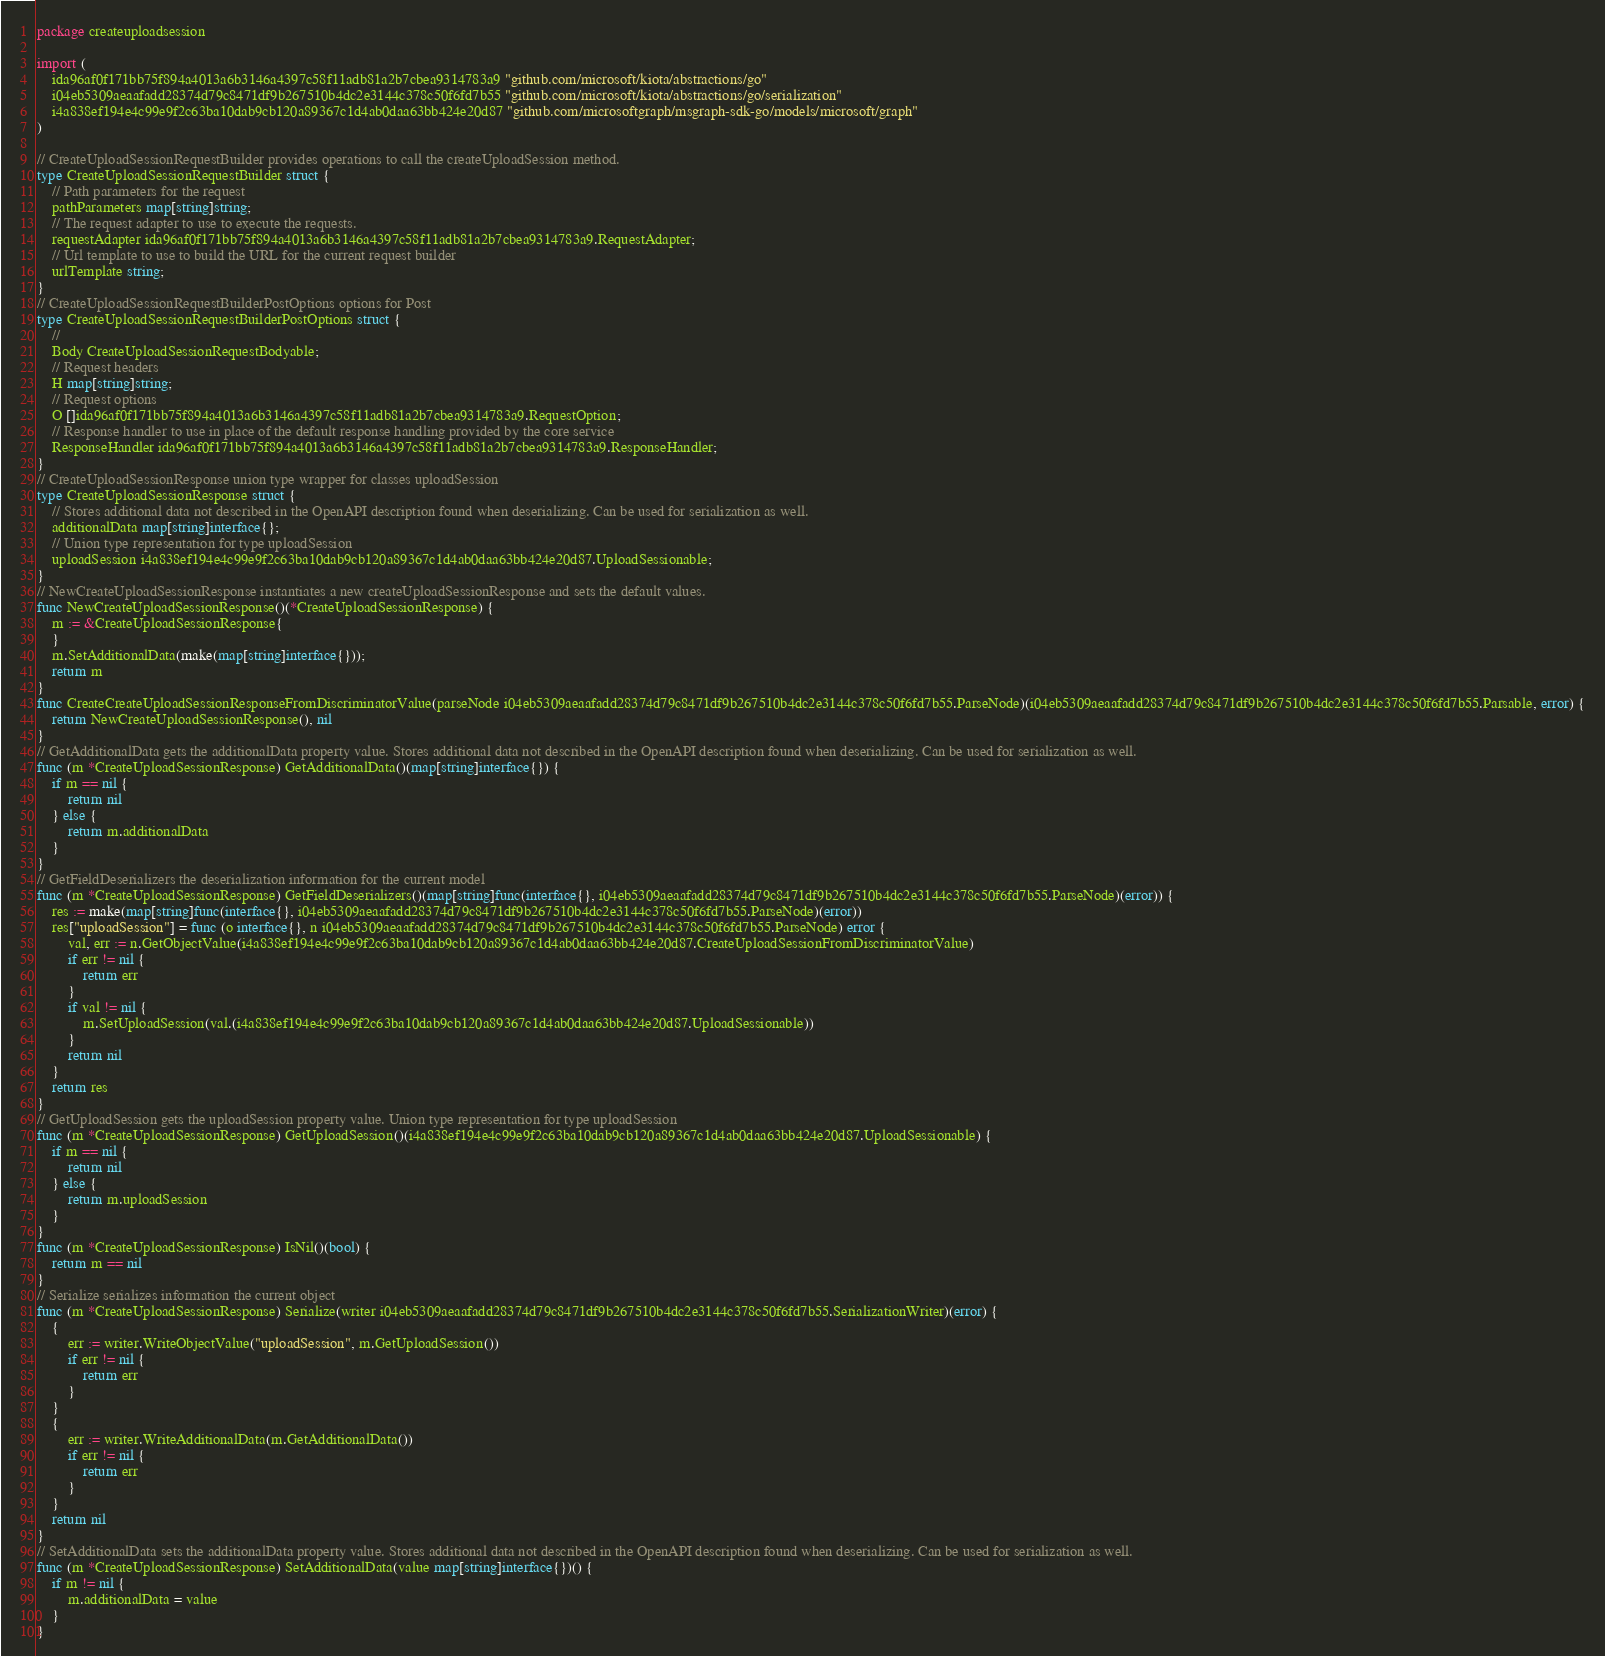Convert code to text. <code><loc_0><loc_0><loc_500><loc_500><_Go_>package createuploadsession

import (
    ida96af0f171bb75f894a4013a6b3146a4397c58f11adb81a2b7cbea9314783a9 "github.com/microsoft/kiota/abstractions/go"
    i04eb5309aeaafadd28374d79c8471df9b267510b4dc2e3144c378c50f6fd7b55 "github.com/microsoft/kiota/abstractions/go/serialization"
    i4a838ef194e4c99e9f2c63ba10dab9cb120a89367c1d4ab0daa63bb424e20d87 "github.com/microsoftgraph/msgraph-sdk-go/models/microsoft/graph"
)

// CreateUploadSessionRequestBuilder provides operations to call the createUploadSession method.
type CreateUploadSessionRequestBuilder struct {
    // Path parameters for the request
    pathParameters map[string]string;
    // The request adapter to use to execute the requests.
    requestAdapter ida96af0f171bb75f894a4013a6b3146a4397c58f11adb81a2b7cbea9314783a9.RequestAdapter;
    // Url template to use to build the URL for the current request builder
    urlTemplate string;
}
// CreateUploadSessionRequestBuilderPostOptions options for Post
type CreateUploadSessionRequestBuilderPostOptions struct {
    // 
    Body CreateUploadSessionRequestBodyable;
    // Request headers
    H map[string]string;
    // Request options
    O []ida96af0f171bb75f894a4013a6b3146a4397c58f11adb81a2b7cbea9314783a9.RequestOption;
    // Response handler to use in place of the default response handling provided by the core service
    ResponseHandler ida96af0f171bb75f894a4013a6b3146a4397c58f11adb81a2b7cbea9314783a9.ResponseHandler;
}
// CreateUploadSessionResponse union type wrapper for classes uploadSession
type CreateUploadSessionResponse struct {
    // Stores additional data not described in the OpenAPI description found when deserializing. Can be used for serialization as well.
    additionalData map[string]interface{};
    // Union type representation for type uploadSession
    uploadSession i4a838ef194e4c99e9f2c63ba10dab9cb120a89367c1d4ab0daa63bb424e20d87.UploadSessionable;
}
// NewCreateUploadSessionResponse instantiates a new createUploadSessionResponse and sets the default values.
func NewCreateUploadSessionResponse()(*CreateUploadSessionResponse) {
    m := &CreateUploadSessionResponse{
    }
    m.SetAdditionalData(make(map[string]interface{}));
    return m
}
func CreateCreateUploadSessionResponseFromDiscriminatorValue(parseNode i04eb5309aeaafadd28374d79c8471df9b267510b4dc2e3144c378c50f6fd7b55.ParseNode)(i04eb5309aeaafadd28374d79c8471df9b267510b4dc2e3144c378c50f6fd7b55.Parsable, error) {
    return NewCreateUploadSessionResponse(), nil
}
// GetAdditionalData gets the additionalData property value. Stores additional data not described in the OpenAPI description found when deserializing. Can be used for serialization as well.
func (m *CreateUploadSessionResponse) GetAdditionalData()(map[string]interface{}) {
    if m == nil {
        return nil
    } else {
        return m.additionalData
    }
}
// GetFieldDeserializers the deserialization information for the current model
func (m *CreateUploadSessionResponse) GetFieldDeserializers()(map[string]func(interface{}, i04eb5309aeaafadd28374d79c8471df9b267510b4dc2e3144c378c50f6fd7b55.ParseNode)(error)) {
    res := make(map[string]func(interface{}, i04eb5309aeaafadd28374d79c8471df9b267510b4dc2e3144c378c50f6fd7b55.ParseNode)(error))
    res["uploadSession"] = func (o interface{}, n i04eb5309aeaafadd28374d79c8471df9b267510b4dc2e3144c378c50f6fd7b55.ParseNode) error {
        val, err := n.GetObjectValue(i4a838ef194e4c99e9f2c63ba10dab9cb120a89367c1d4ab0daa63bb424e20d87.CreateUploadSessionFromDiscriminatorValue)
        if err != nil {
            return err
        }
        if val != nil {
            m.SetUploadSession(val.(i4a838ef194e4c99e9f2c63ba10dab9cb120a89367c1d4ab0daa63bb424e20d87.UploadSessionable))
        }
        return nil
    }
    return res
}
// GetUploadSession gets the uploadSession property value. Union type representation for type uploadSession
func (m *CreateUploadSessionResponse) GetUploadSession()(i4a838ef194e4c99e9f2c63ba10dab9cb120a89367c1d4ab0daa63bb424e20d87.UploadSessionable) {
    if m == nil {
        return nil
    } else {
        return m.uploadSession
    }
}
func (m *CreateUploadSessionResponse) IsNil()(bool) {
    return m == nil
}
// Serialize serializes information the current object
func (m *CreateUploadSessionResponse) Serialize(writer i04eb5309aeaafadd28374d79c8471df9b267510b4dc2e3144c378c50f6fd7b55.SerializationWriter)(error) {
    {
        err := writer.WriteObjectValue("uploadSession", m.GetUploadSession())
        if err != nil {
            return err
        }
    }
    {
        err := writer.WriteAdditionalData(m.GetAdditionalData())
        if err != nil {
            return err
        }
    }
    return nil
}
// SetAdditionalData sets the additionalData property value. Stores additional data not described in the OpenAPI description found when deserializing. Can be used for serialization as well.
func (m *CreateUploadSessionResponse) SetAdditionalData(value map[string]interface{})() {
    if m != nil {
        m.additionalData = value
    }
}</code> 